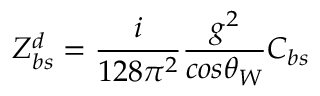Convert formula to latex. <formula><loc_0><loc_0><loc_500><loc_500>Z _ { b s } ^ { d } = \frac { i } { 1 2 8 \pi ^ { 2 } } \frac { g ^ { 2 } } { \cos \theta _ { W } } C _ { b s }</formula> 